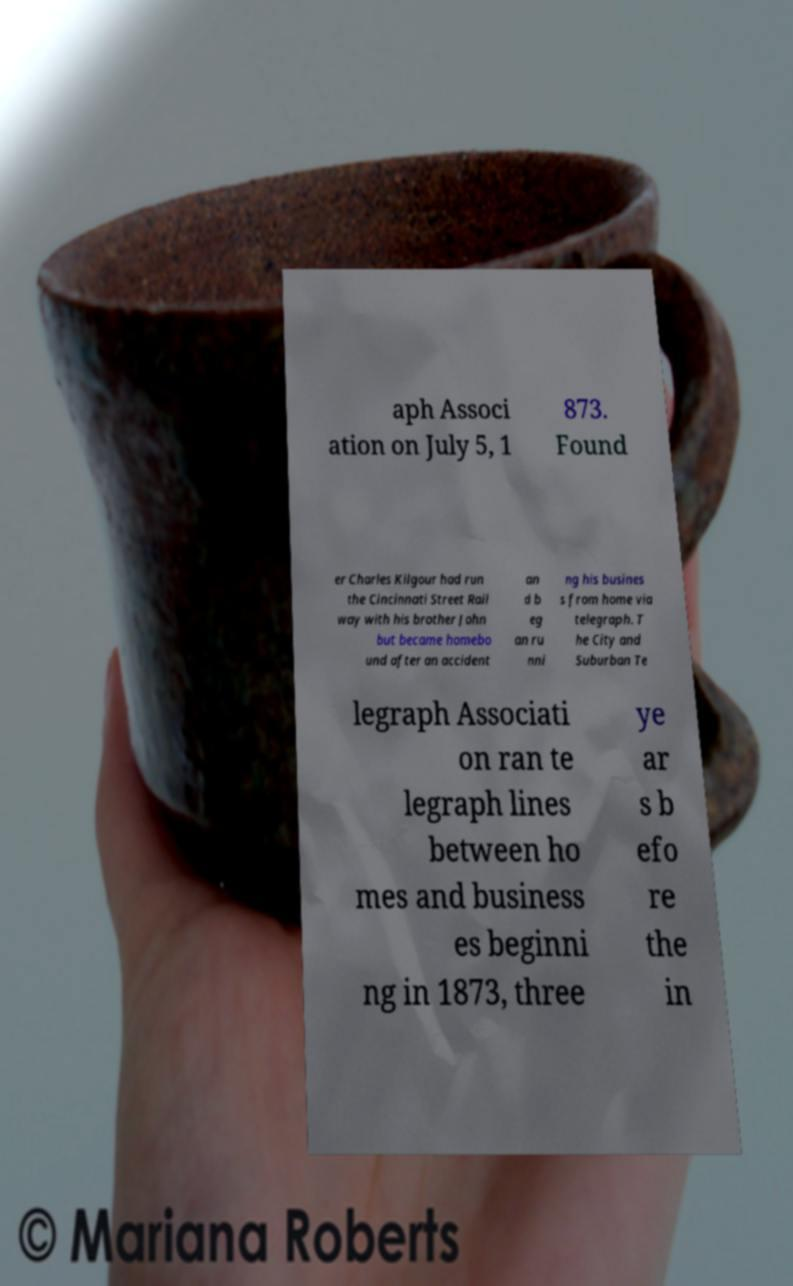There's text embedded in this image that I need extracted. Can you transcribe it verbatim? aph Associ ation on July 5, 1 873. Found er Charles Kilgour had run the Cincinnati Street Rail way with his brother John but became homebo und after an accident an d b eg an ru nni ng his busines s from home via telegraph. T he City and Suburban Te legraph Associati on ran te legraph lines between ho mes and business es beginni ng in 1873, three ye ar s b efo re the in 